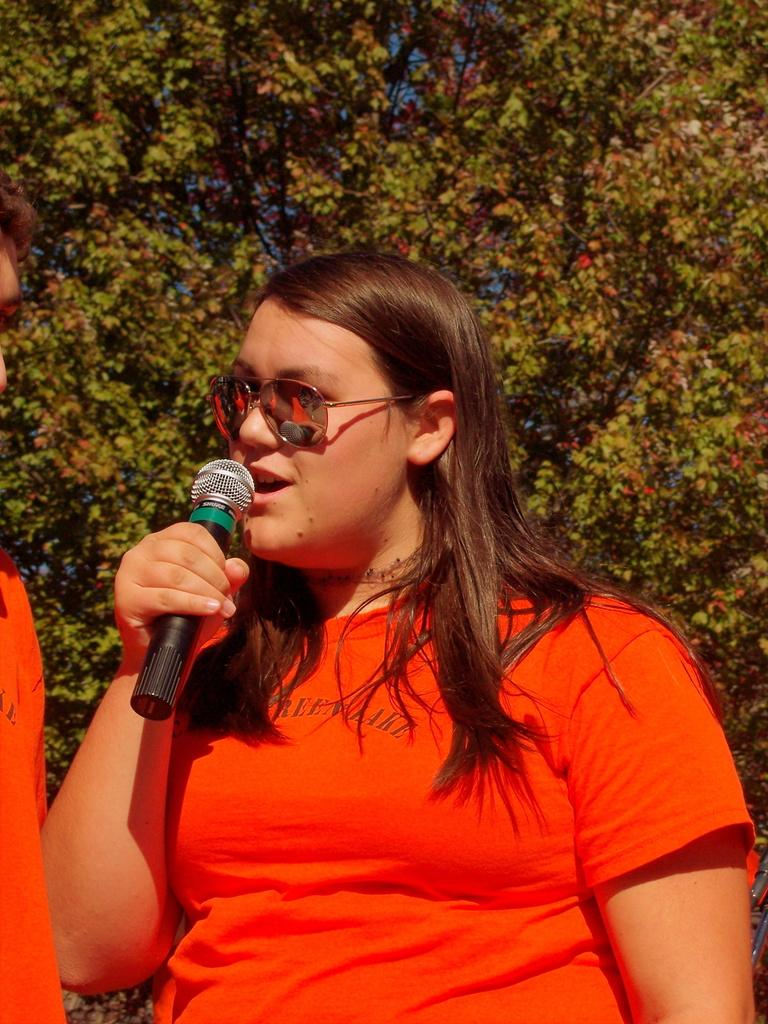What is the main subject of the image? The main subject of the image is a woman. What is the woman holding in the image? The woman is holding a microphone. What is the woman wearing in the image? The woman is wearing a red T-shirt. What can be seen in the background of the image? There are trees in the background of the image. How many goldfish are swimming in the background of the image? There are no goldfish present in the image; the background features trees. 